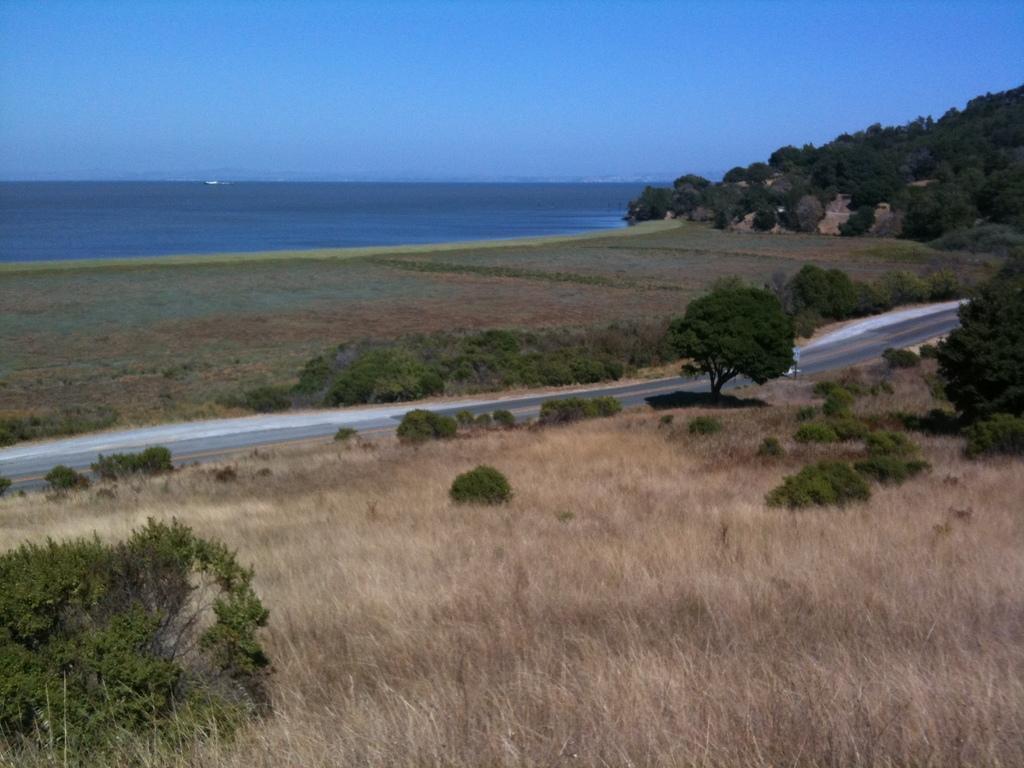Can you describe this image briefly? In this picture there are few plants and dried grass and there is road beside it and there are trees and greenery ground on another side of the road and there is water in background. 